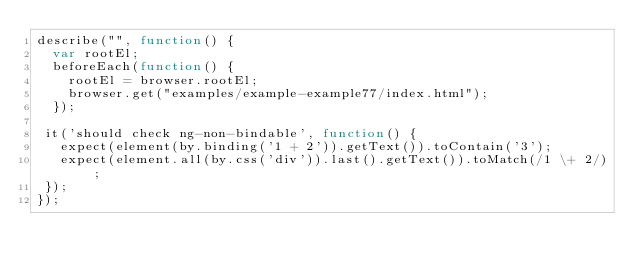Convert code to text. <code><loc_0><loc_0><loc_500><loc_500><_JavaScript_>describe("", function() {
  var rootEl;
  beforeEach(function() {
    rootEl = browser.rootEl;
    browser.get("examples/example-example77/index.html");
  });
  
 it('should check ng-non-bindable', function() {
   expect(element(by.binding('1 + 2')).getText()).toContain('3');
   expect(element.all(by.css('div')).last().getText()).toMatch(/1 \+ 2/);
 });
});</code> 